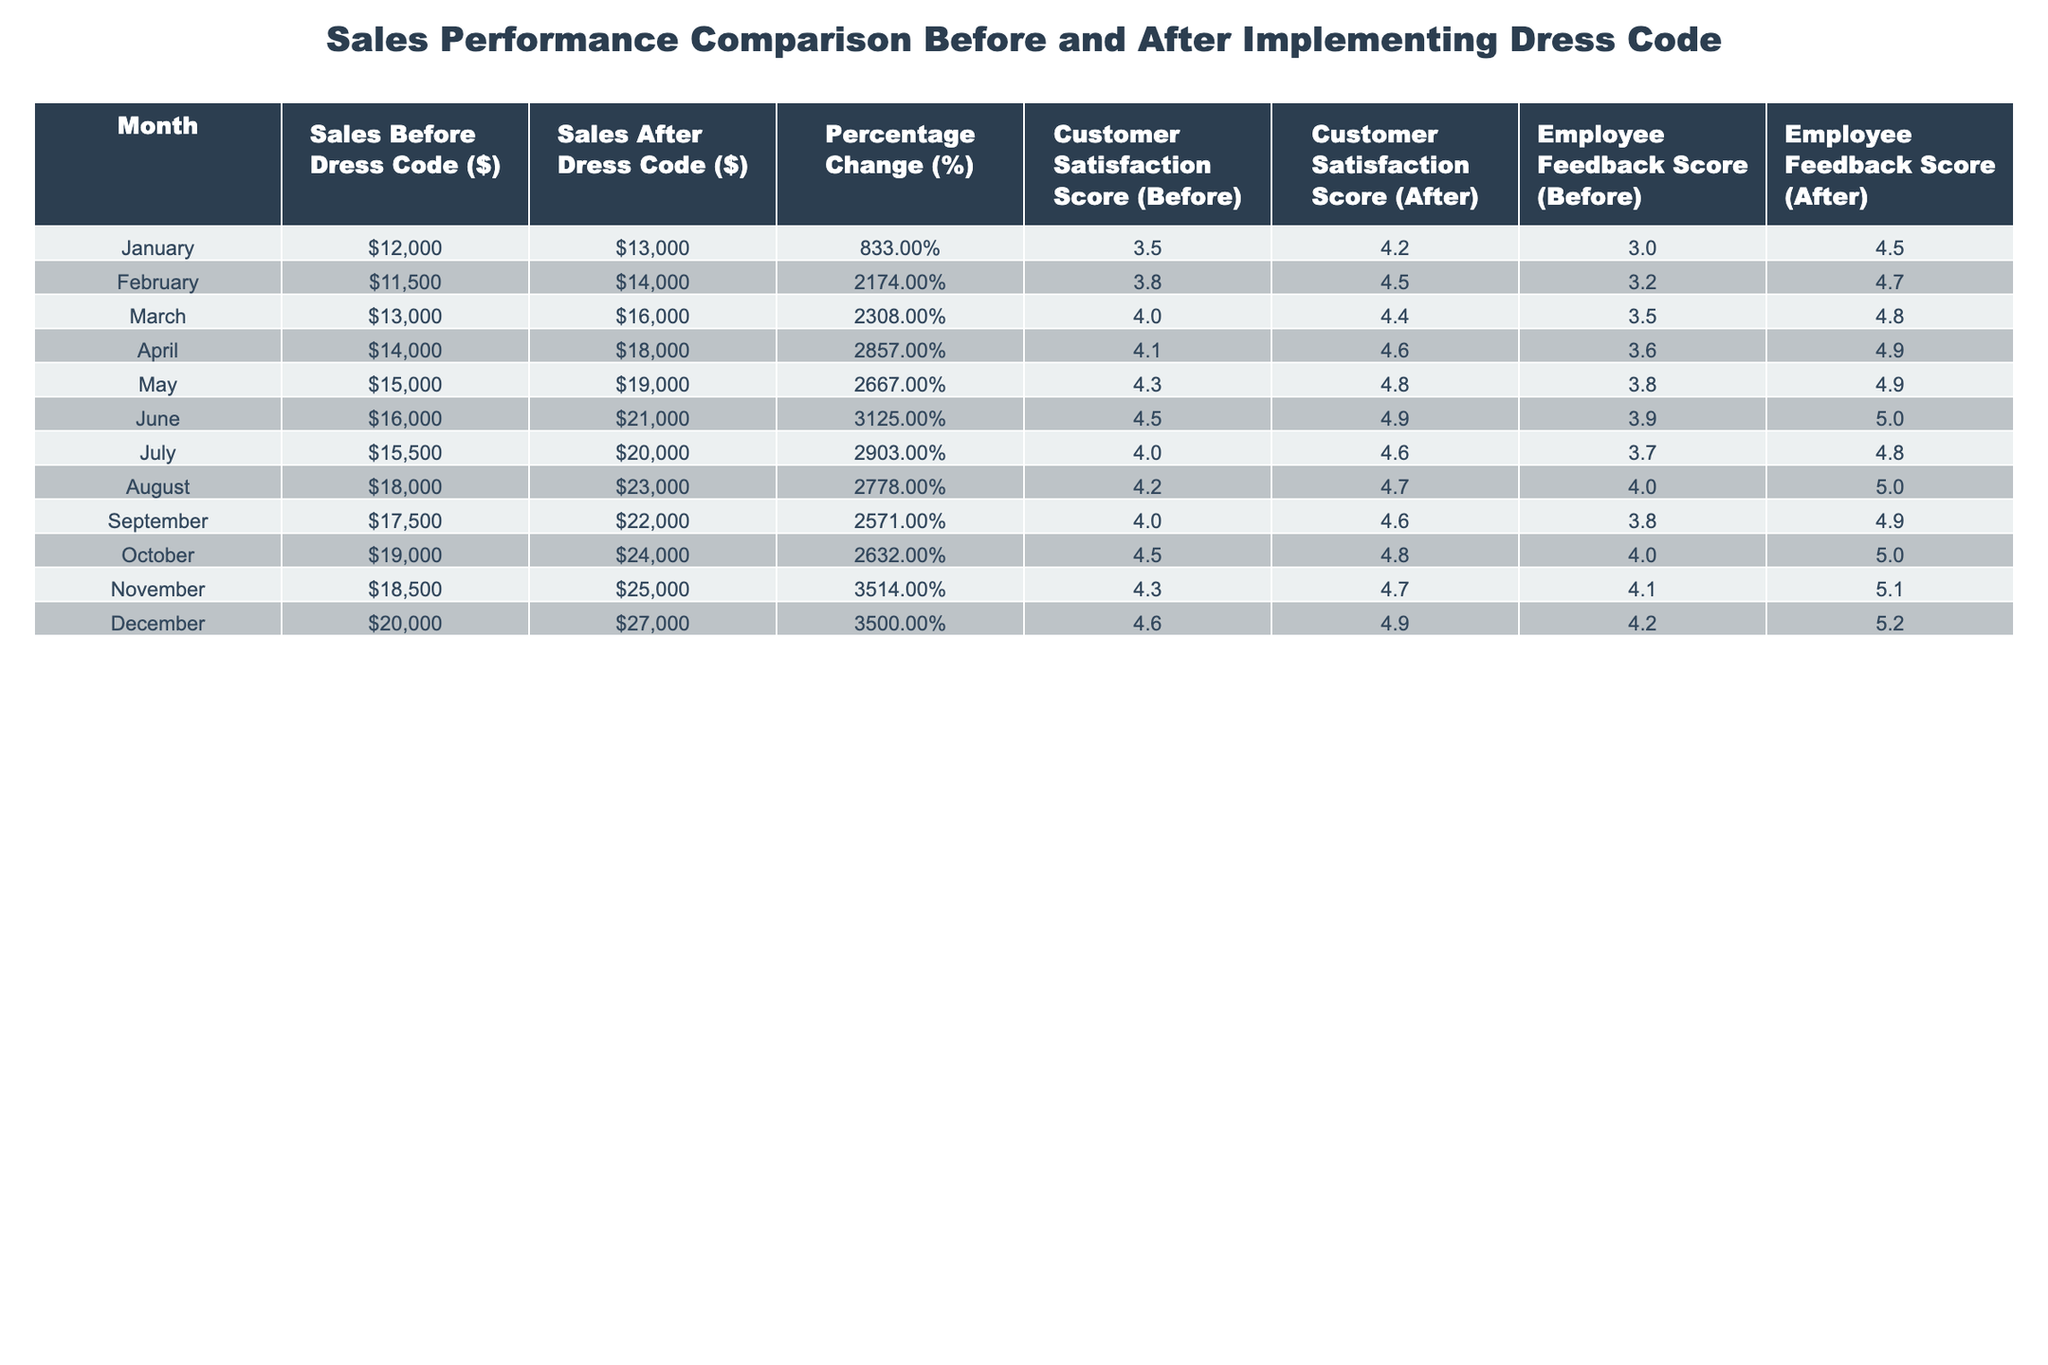What was the total sales before the dress code implementation in March? According to the table, the sales before the dress code implementation in March was $13,000. This value is directly located in the "Sales Before Dress Code ($)" column for the month of March.
Answer: $13,000 What was the percentage change in sales from July to August? The sales before and after the dress code for July are $15,500 and $20,000 respectively, and for August, they were $18,000 and $23,000. The percentage change from July to August is calculated as: ((23,000 - 20,000) / 20,000) * 100 = 15%.
Answer: 15% Did customer satisfaction increase after implementing the dress code in all months? To determine this, we look at the "Customer Satisfaction Score (Before)" and "Customer Satisfaction Score (After)" columns. In each month, the scores after implementing the dress code are higher than those before, indicating that customer satisfaction increased in all months.
Answer: Yes Which month had the highest increase in employee feedback score after the dress code was implemented? By reviewing the "Employee Feedback Score (Before)" and "Employee Feedback Score (After)" columns, we calculate the increase for each month. The highest increase is in November, where the score rose from 4.1 to 5.1, giving an increase of 1.0.
Answer: November What is the average customer satisfaction score before implementing the dress code across all months? To find the average, we sum the "Customer Satisfaction Score (Before)" across all months: (3.5 + 3.8 + 4.0 + 4.1 + 4.3 + 4.5 + 4.0 + 4.2 + 4.0 + 4.5 + 4.3 + 4.6) = 50.8, and then divide by the number of months (12): 50.8 / 12 = approximately 4.23.
Answer: 4.23 What was the difference in sales before dress code implementation between December and January? The sales before dress code in December were $20,000 and in January were $12,000. The difference is calculated by subtracting January's sales from December's: 20,000 - 12,000 = 8,000.
Answer: $8,000 Which month showed the largest improvement in both customer satisfaction and sales after the dress code was implemented? Analyzing the "Customer Satisfaction Score" and "Sales After Dress Code" columns, April had a significant sales increase to $18,000 and a customer satisfaction score rise to 4.6. This is noted for being one of the larger increases in both metrics.
Answer: April 